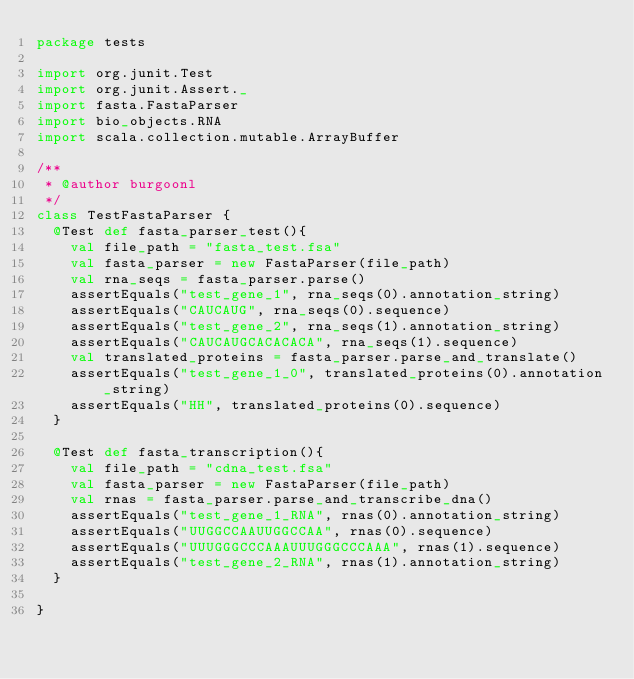<code> <loc_0><loc_0><loc_500><loc_500><_Scala_>package tests

import org.junit.Test
import org.junit.Assert._
import fasta.FastaParser
import bio_objects.RNA
import scala.collection.mutable.ArrayBuffer

/**
 * @author burgoonl
 */
class TestFastaParser {
  @Test def fasta_parser_test(){
    val file_path = "fasta_test.fsa"
    val fasta_parser = new FastaParser(file_path)
    val rna_seqs = fasta_parser.parse()
    assertEquals("test_gene_1", rna_seqs(0).annotation_string)
    assertEquals("CAUCAUG", rna_seqs(0).sequence)
    assertEquals("test_gene_2", rna_seqs(1).annotation_string)
    assertEquals("CAUCAUGCACACACA", rna_seqs(1).sequence)
    val translated_proteins = fasta_parser.parse_and_translate()
    assertEquals("test_gene_1_0", translated_proteins(0).annotation_string)
    assertEquals("HH", translated_proteins(0).sequence)
  }
  
  @Test def fasta_transcription(){
    val file_path = "cdna_test.fsa"
    val fasta_parser = new FastaParser(file_path)
    val rnas = fasta_parser.parse_and_transcribe_dna()
    assertEquals("test_gene_1_RNA", rnas(0).annotation_string)
    assertEquals("UUGGCCAAUUGGCCAA", rnas(0).sequence)
    assertEquals("UUUGGGCCCAAAUUUGGGCCCAAA", rnas(1).sequence)
    assertEquals("test_gene_2_RNA", rnas(1).annotation_string)
  }
  
}</code> 